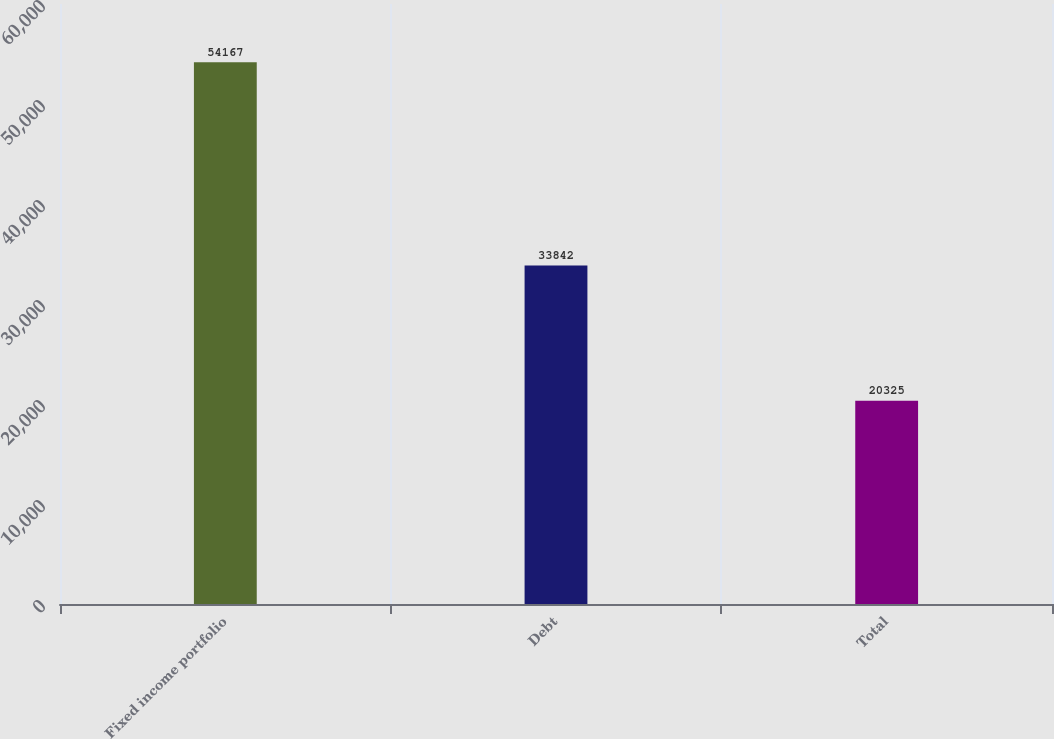<chart> <loc_0><loc_0><loc_500><loc_500><bar_chart><fcel>Fixed income portfolio<fcel>Debt<fcel>Total<nl><fcel>54167<fcel>33842<fcel>20325<nl></chart> 